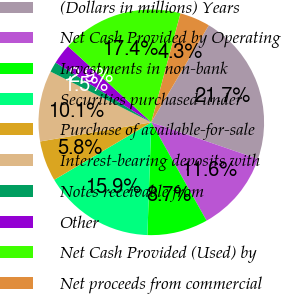<chart> <loc_0><loc_0><loc_500><loc_500><pie_chart><fcel>(Dollars in millions) Years<fcel>Net Cash Provided by Operating<fcel>Investments in non-bank<fcel>Securities purchased under<fcel>Purchase of available-for-sale<fcel>Interest-bearing deposits with<fcel>Notes receivable from<fcel>Other<fcel>Net Cash Provided (Used) by<fcel>Net proceeds from commercial<nl><fcel>21.74%<fcel>11.59%<fcel>8.7%<fcel>15.94%<fcel>5.8%<fcel>10.14%<fcel>1.45%<fcel>2.9%<fcel>17.39%<fcel>4.35%<nl></chart> 